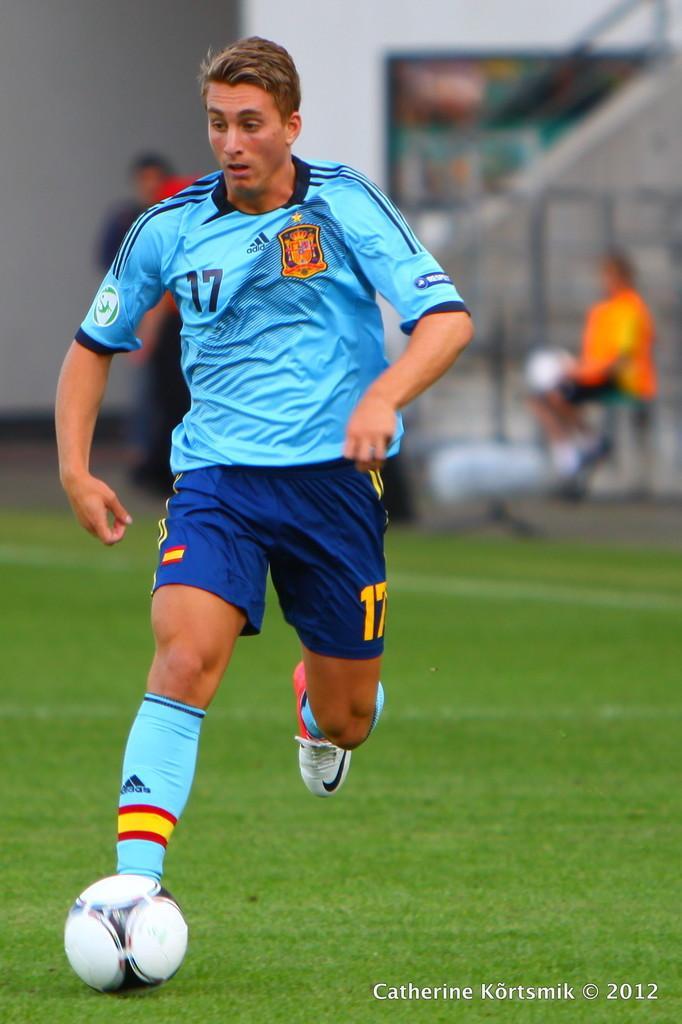Can you describe this image briefly? This Picture describe about the man playing football in the green field wearing light blue t- shirt and a dark blue shots with a white ball in his foot. Behind we can see other players are sitting on the chairs wearing orange t- shirt and stairs going up to the stadium hall. 